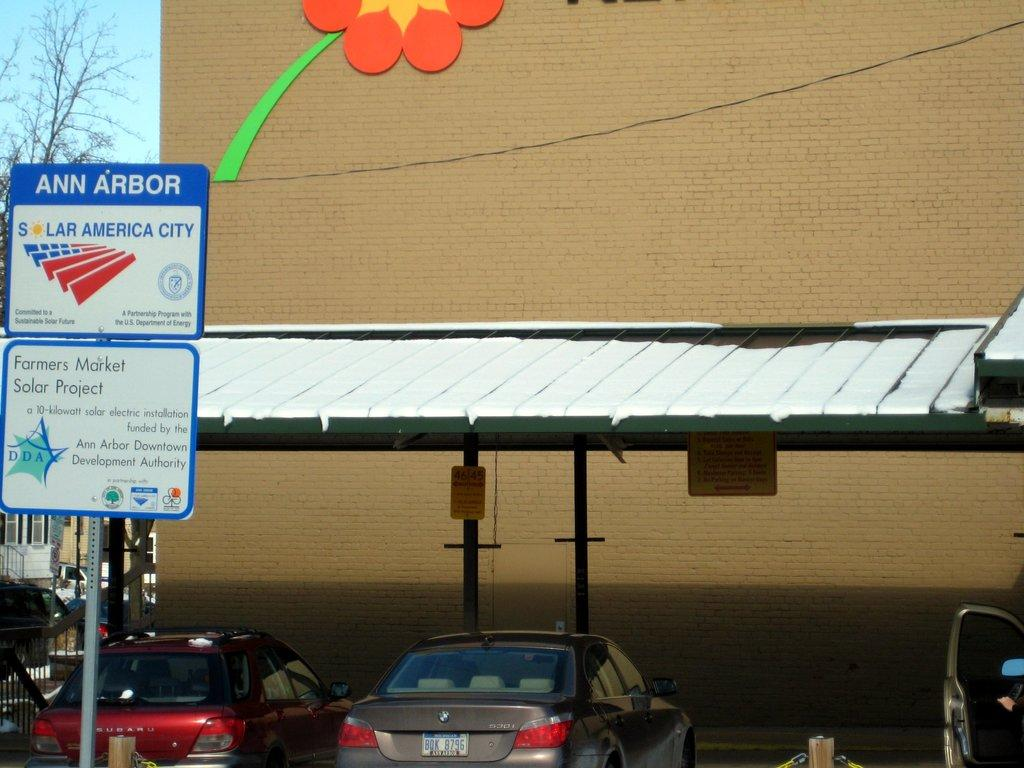What type of art can be seen on the building in the image? There is art on the building in the image, but the specific type cannot be determined from the facts provided. What material is visible in the image? Shred, vehicles, poles, boards with text, images, wire, and trees are visible in the image. What is the purpose of the boards with text in the image? The purpose of the boards with text in the image cannot be determined from the facts provided. What is visible in the sky in the image? The sky is visible in the image, but the specific weather conditions or time of day cannot be determined from the facts provided. Where is the garden located in the image? There is no garden present in the image. What type of plant is growing on the wire in the image? There is no plant growing on the wire in the image. 